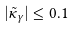Convert formula to latex. <formula><loc_0><loc_0><loc_500><loc_500>| \tilde { \kappa } _ { \gamma } | \leq 0 . 1</formula> 